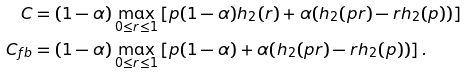Convert formula to latex. <formula><loc_0><loc_0><loc_500><loc_500>C & = ( 1 - \alpha ) \max _ { 0 \leq r \leq 1 } \left [ p ( 1 - \alpha ) h _ { 2 } ( r ) + \alpha ( h _ { 2 } ( p r ) - r h _ { 2 } ( p ) ) \right ] \\ C _ { f b } & = ( 1 - \alpha ) \max _ { 0 \leq r \leq 1 } \left [ p ( 1 - \alpha ) + \alpha ( h _ { 2 } ( p r ) - r h _ { 2 } ( p ) ) \right ] .</formula> 